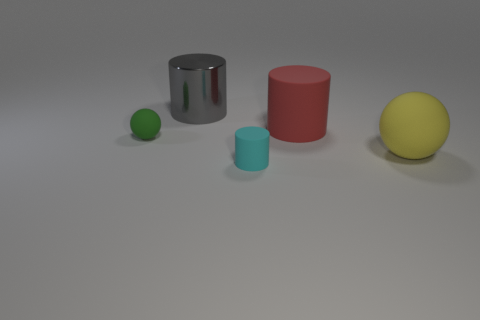There is a cylinder in front of the small rubber sphere; does it have the same size as the object that is on the left side of the gray metal thing?
Your answer should be compact. Yes. How many other things are the same size as the red thing?
Provide a short and direct response. 2. How many things are red matte objects behind the yellow rubber thing or matte things that are in front of the small green rubber thing?
Give a very brief answer. 3. Is the material of the large gray cylinder the same as the tiny thing behind the cyan cylinder?
Ensure brevity in your answer.  No. What number of other objects are the same shape as the big yellow rubber thing?
Provide a short and direct response. 1. What material is the ball in front of the tiny object that is behind the cylinder that is in front of the small green matte ball?
Offer a terse response. Rubber. Is the number of yellow rubber objects that are to the right of the large metal object the same as the number of small green objects?
Your answer should be compact. Yes. Does the large object in front of the green matte sphere have the same material as the ball that is on the left side of the large red rubber cylinder?
Keep it short and to the point. Yes. Are there any other things that have the same material as the tiny ball?
Your answer should be very brief. Yes. There is a tiny thing that is left of the cyan matte cylinder; is its shape the same as the thing that is in front of the large yellow matte object?
Your answer should be compact. No. 